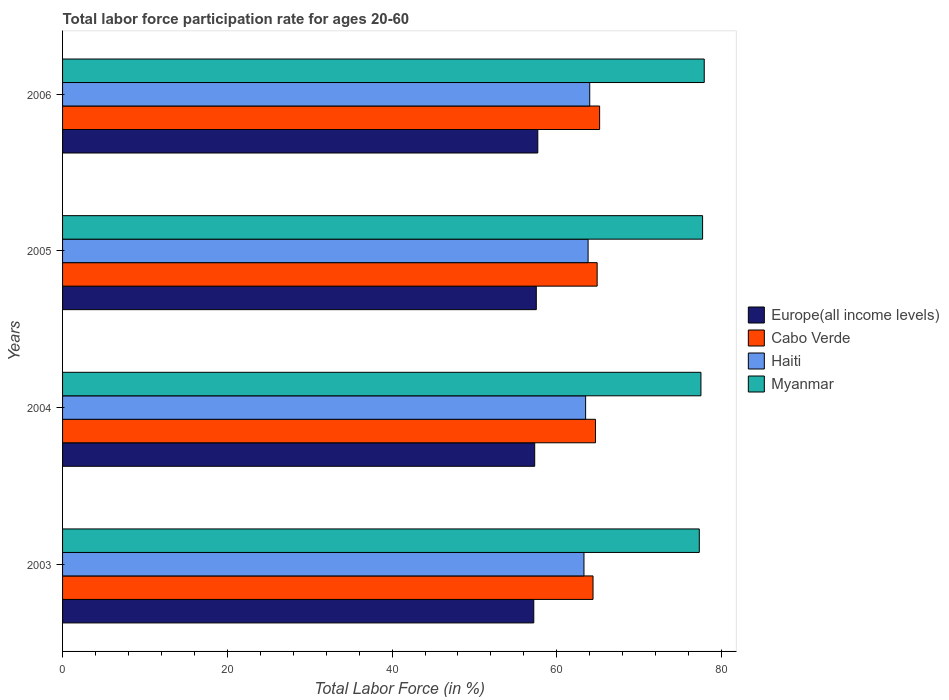How many bars are there on the 2nd tick from the bottom?
Your answer should be very brief. 4. What is the label of the 1st group of bars from the top?
Give a very brief answer. 2006. What is the labor force participation rate in Myanmar in 2006?
Ensure brevity in your answer.  77.9. Across all years, what is the maximum labor force participation rate in Haiti?
Provide a succinct answer. 64. Across all years, what is the minimum labor force participation rate in Europe(all income levels)?
Offer a terse response. 57.21. In which year was the labor force participation rate in Haiti maximum?
Offer a terse response. 2006. In which year was the labor force participation rate in Haiti minimum?
Give a very brief answer. 2003. What is the total labor force participation rate in Europe(all income levels) in the graph?
Provide a succinct answer. 229.73. What is the difference between the labor force participation rate in Europe(all income levels) in 2003 and that in 2004?
Provide a succinct answer. -0.11. What is the difference between the labor force participation rate in Cabo Verde in 2004 and the labor force participation rate in Myanmar in 2003?
Offer a terse response. -12.6. What is the average labor force participation rate in Cabo Verde per year?
Offer a terse response. 64.8. In the year 2005, what is the difference between the labor force participation rate in Europe(all income levels) and labor force participation rate in Haiti?
Keep it short and to the point. -6.29. What is the ratio of the labor force participation rate in Haiti in 2004 to that in 2006?
Keep it short and to the point. 0.99. What is the difference between the highest and the second highest labor force participation rate in Myanmar?
Ensure brevity in your answer.  0.2. What is the difference between the highest and the lowest labor force participation rate in Cabo Verde?
Your response must be concise. 0.8. Is it the case that in every year, the sum of the labor force participation rate in Europe(all income levels) and labor force participation rate in Haiti is greater than the sum of labor force participation rate in Myanmar and labor force participation rate in Cabo Verde?
Offer a very short reply. No. What does the 4th bar from the top in 2003 represents?
Offer a terse response. Europe(all income levels). What does the 3rd bar from the bottom in 2003 represents?
Provide a succinct answer. Haiti. How many bars are there?
Give a very brief answer. 16. How many years are there in the graph?
Make the answer very short. 4. Are the values on the major ticks of X-axis written in scientific E-notation?
Your answer should be very brief. No. Does the graph contain any zero values?
Your answer should be very brief. No. Does the graph contain grids?
Your response must be concise. No. Where does the legend appear in the graph?
Keep it short and to the point. Center right. What is the title of the graph?
Provide a short and direct response. Total labor force participation rate for ages 20-60. Does "New Caledonia" appear as one of the legend labels in the graph?
Offer a very short reply. No. What is the Total Labor Force (in %) in Europe(all income levels) in 2003?
Your response must be concise. 57.21. What is the Total Labor Force (in %) in Cabo Verde in 2003?
Ensure brevity in your answer.  64.4. What is the Total Labor Force (in %) in Haiti in 2003?
Ensure brevity in your answer.  63.3. What is the Total Labor Force (in %) of Myanmar in 2003?
Keep it short and to the point. 77.3. What is the Total Labor Force (in %) in Europe(all income levels) in 2004?
Offer a terse response. 57.32. What is the Total Labor Force (in %) in Cabo Verde in 2004?
Your answer should be compact. 64.7. What is the Total Labor Force (in %) of Haiti in 2004?
Provide a succinct answer. 63.5. What is the Total Labor Force (in %) of Myanmar in 2004?
Your response must be concise. 77.5. What is the Total Labor Force (in %) of Europe(all income levels) in 2005?
Offer a very short reply. 57.51. What is the Total Labor Force (in %) in Cabo Verde in 2005?
Provide a short and direct response. 64.9. What is the Total Labor Force (in %) of Haiti in 2005?
Offer a very short reply. 63.8. What is the Total Labor Force (in %) in Myanmar in 2005?
Keep it short and to the point. 77.7. What is the Total Labor Force (in %) in Europe(all income levels) in 2006?
Offer a very short reply. 57.69. What is the Total Labor Force (in %) of Cabo Verde in 2006?
Your response must be concise. 65.2. What is the Total Labor Force (in %) in Myanmar in 2006?
Ensure brevity in your answer.  77.9. Across all years, what is the maximum Total Labor Force (in %) of Europe(all income levels)?
Give a very brief answer. 57.69. Across all years, what is the maximum Total Labor Force (in %) of Cabo Verde?
Offer a very short reply. 65.2. Across all years, what is the maximum Total Labor Force (in %) in Haiti?
Offer a very short reply. 64. Across all years, what is the maximum Total Labor Force (in %) in Myanmar?
Provide a succinct answer. 77.9. Across all years, what is the minimum Total Labor Force (in %) of Europe(all income levels)?
Keep it short and to the point. 57.21. Across all years, what is the minimum Total Labor Force (in %) in Cabo Verde?
Give a very brief answer. 64.4. Across all years, what is the minimum Total Labor Force (in %) in Haiti?
Provide a short and direct response. 63.3. Across all years, what is the minimum Total Labor Force (in %) in Myanmar?
Offer a terse response. 77.3. What is the total Total Labor Force (in %) in Europe(all income levels) in the graph?
Offer a terse response. 229.73. What is the total Total Labor Force (in %) of Cabo Verde in the graph?
Keep it short and to the point. 259.2. What is the total Total Labor Force (in %) in Haiti in the graph?
Provide a short and direct response. 254.6. What is the total Total Labor Force (in %) of Myanmar in the graph?
Offer a very short reply. 310.4. What is the difference between the Total Labor Force (in %) in Europe(all income levels) in 2003 and that in 2004?
Keep it short and to the point. -0.11. What is the difference between the Total Labor Force (in %) in Cabo Verde in 2003 and that in 2004?
Keep it short and to the point. -0.3. What is the difference between the Total Labor Force (in %) of Haiti in 2003 and that in 2004?
Make the answer very short. -0.2. What is the difference between the Total Labor Force (in %) of Europe(all income levels) in 2003 and that in 2005?
Your response must be concise. -0.3. What is the difference between the Total Labor Force (in %) of Cabo Verde in 2003 and that in 2005?
Your response must be concise. -0.5. What is the difference between the Total Labor Force (in %) of Myanmar in 2003 and that in 2005?
Offer a very short reply. -0.4. What is the difference between the Total Labor Force (in %) of Europe(all income levels) in 2003 and that in 2006?
Your answer should be very brief. -0.49. What is the difference between the Total Labor Force (in %) in Cabo Verde in 2003 and that in 2006?
Provide a succinct answer. -0.8. What is the difference between the Total Labor Force (in %) of Myanmar in 2003 and that in 2006?
Keep it short and to the point. -0.6. What is the difference between the Total Labor Force (in %) in Europe(all income levels) in 2004 and that in 2005?
Keep it short and to the point. -0.19. What is the difference between the Total Labor Force (in %) in Cabo Verde in 2004 and that in 2005?
Offer a terse response. -0.2. What is the difference between the Total Labor Force (in %) in Haiti in 2004 and that in 2005?
Offer a terse response. -0.3. What is the difference between the Total Labor Force (in %) of Myanmar in 2004 and that in 2005?
Offer a very short reply. -0.2. What is the difference between the Total Labor Force (in %) of Europe(all income levels) in 2004 and that in 2006?
Give a very brief answer. -0.37. What is the difference between the Total Labor Force (in %) of Cabo Verde in 2004 and that in 2006?
Provide a short and direct response. -0.5. What is the difference between the Total Labor Force (in %) in Europe(all income levels) in 2005 and that in 2006?
Offer a terse response. -0.18. What is the difference between the Total Labor Force (in %) of Cabo Verde in 2005 and that in 2006?
Make the answer very short. -0.3. What is the difference between the Total Labor Force (in %) of Europe(all income levels) in 2003 and the Total Labor Force (in %) of Cabo Verde in 2004?
Make the answer very short. -7.49. What is the difference between the Total Labor Force (in %) of Europe(all income levels) in 2003 and the Total Labor Force (in %) of Haiti in 2004?
Make the answer very short. -6.29. What is the difference between the Total Labor Force (in %) in Europe(all income levels) in 2003 and the Total Labor Force (in %) in Myanmar in 2004?
Give a very brief answer. -20.29. What is the difference between the Total Labor Force (in %) in Cabo Verde in 2003 and the Total Labor Force (in %) in Haiti in 2004?
Your answer should be very brief. 0.9. What is the difference between the Total Labor Force (in %) of Haiti in 2003 and the Total Labor Force (in %) of Myanmar in 2004?
Your answer should be very brief. -14.2. What is the difference between the Total Labor Force (in %) in Europe(all income levels) in 2003 and the Total Labor Force (in %) in Cabo Verde in 2005?
Offer a terse response. -7.69. What is the difference between the Total Labor Force (in %) in Europe(all income levels) in 2003 and the Total Labor Force (in %) in Haiti in 2005?
Make the answer very short. -6.59. What is the difference between the Total Labor Force (in %) in Europe(all income levels) in 2003 and the Total Labor Force (in %) in Myanmar in 2005?
Provide a short and direct response. -20.49. What is the difference between the Total Labor Force (in %) of Cabo Verde in 2003 and the Total Labor Force (in %) of Haiti in 2005?
Give a very brief answer. 0.6. What is the difference between the Total Labor Force (in %) in Haiti in 2003 and the Total Labor Force (in %) in Myanmar in 2005?
Offer a terse response. -14.4. What is the difference between the Total Labor Force (in %) in Europe(all income levels) in 2003 and the Total Labor Force (in %) in Cabo Verde in 2006?
Make the answer very short. -7.99. What is the difference between the Total Labor Force (in %) in Europe(all income levels) in 2003 and the Total Labor Force (in %) in Haiti in 2006?
Offer a terse response. -6.79. What is the difference between the Total Labor Force (in %) in Europe(all income levels) in 2003 and the Total Labor Force (in %) in Myanmar in 2006?
Ensure brevity in your answer.  -20.69. What is the difference between the Total Labor Force (in %) in Haiti in 2003 and the Total Labor Force (in %) in Myanmar in 2006?
Offer a very short reply. -14.6. What is the difference between the Total Labor Force (in %) in Europe(all income levels) in 2004 and the Total Labor Force (in %) in Cabo Verde in 2005?
Your response must be concise. -7.58. What is the difference between the Total Labor Force (in %) in Europe(all income levels) in 2004 and the Total Labor Force (in %) in Haiti in 2005?
Give a very brief answer. -6.48. What is the difference between the Total Labor Force (in %) in Europe(all income levels) in 2004 and the Total Labor Force (in %) in Myanmar in 2005?
Keep it short and to the point. -20.38. What is the difference between the Total Labor Force (in %) in Cabo Verde in 2004 and the Total Labor Force (in %) in Myanmar in 2005?
Give a very brief answer. -13. What is the difference between the Total Labor Force (in %) of Europe(all income levels) in 2004 and the Total Labor Force (in %) of Cabo Verde in 2006?
Provide a short and direct response. -7.88. What is the difference between the Total Labor Force (in %) in Europe(all income levels) in 2004 and the Total Labor Force (in %) in Haiti in 2006?
Ensure brevity in your answer.  -6.68. What is the difference between the Total Labor Force (in %) of Europe(all income levels) in 2004 and the Total Labor Force (in %) of Myanmar in 2006?
Make the answer very short. -20.58. What is the difference between the Total Labor Force (in %) in Cabo Verde in 2004 and the Total Labor Force (in %) in Myanmar in 2006?
Your answer should be compact. -13.2. What is the difference between the Total Labor Force (in %) in Haiti in 2004 and the Total Labor Force (in %) in Myanmar in 2006?
Offer a very short reply. -14.4. What is the difference between the Total Labor Force (in %) of Europe(all income levels) in 2005 and the Total Labor Force (in %) of Cabo Verde in 2006?
Provide a succinct answer. -7.69. What is the difference between the Total Labor Force (in %) in Europe(all income levels) in 2005 and the Total Labor Force (in %) in Haiti in 2006?
Your answer should be very brief. -6.49. What is the difference between the Total Labor Force (in %) in Europe(all income levels) in 2005 and the Total Labor Force (in %) in Myanmar in 2006?
Make the answer very short. -20.39. What is the difference between the Total Labor Force (in %) in Cabo Verde in 2005 and the Total Labor Force (in %) in Haiti in 2006?
Offer a very short reply. 0.9. What is the difference between the Total Labor Force (in %) of Cabo Verde in 2005 and the Total Labor Force (in %) of Myanmar in 2006?
Provide a short and direct response. -13. What is the difference between the Total Labor Force (in %) of Haiti in 2005 and the Total Labor Force (in %) of Myanmar in 2006?
Keep it short and to the point. -14.1. What is the average Total Labor Force (in %) in Europe(all income levels) per year?
Your response must be concise. 57.43. What is the average Total Labor Force (in %) of Cabo Verde per year?
Provide a succinct answer. 64.8. What is the average Total Labor Force (in %) in Haiti per year?
Your answer should be compact. 63.65. What is the average Total Labor Force (in %) in Myanmar per year?
Offer a terse response. 77.6. In the year 2003, what is the difference between the Total Labor Force (in %) of Europe(all income levels) and Total Labor Force (in %) of Cabo Verde?
Provide a short and direct response. -7.19. In the year 2003, what is the difference between the Total Labor Force (in %) of Europe(all income levels) and Total Labor Force (in %) of Haiti?
Give a very brief answer. -6.09. In the year 2003, what is the difference between the Total Labor Force (in %) in Europe(all income levels) and Total Labor Force (in %) in Myanmar?
Your answer should be very brief. -20.09. In the year 2003, what is the difference between the Total Labor Force (in %) of Cabo Verde and Total Labor Force (in %) of Myanmar?
Your response must be concise. -12.9. In the year 2004, what is the difference between the Total Labor Force (in %) of Europe(all income levels) and Total Labor Force (in %) of Cabo Verde?
Give a very brief answer. -7.38. In the year 2004, what is the difference between the Total Labor Force (in %) in Europe(all income levels) and Total Labor Force (in %) in Haiti?
Keep it short and to the point. -6.18. In the year 2004, what is the difference between the Total Labor Force (in %) of Europe(all income levels) and Total Labor Force (in %) of Myanmar?
Make the answer very short. -20.18. In the year 2004, what is the difference between the Total Labor Force (in %) of Cabo Verde and Total Labor Force (in %) of Haiti?
Provide a short and direct response. 1.2. In the year 2004, what is the difference between the Total Labor Force (in %) in Haiti and Total Labor Force (in %) in Myanmar?
Give a very brief answer. -14. In the year 2005, what is the difference between the Total Labor Force (in %) of Europe(all income levels) and Total Labor Force (in %) of Cabo Verde?
Your answer should be compact. -7.39. In the year 2005, what is the difference between the Total Labor Force (in %) of Europe(all income levels) and Total Labor Force (in %) of Haiti?
Your answer should be compact. -6.29. In the year 2005, what is the difference between the Total Labor Force (in %) of Europe(all income levels) and Total Labor Force (in %) of Myanmar?
Your response must be concise. -20.19. In the year 2005, what is the difference between the Total Labor Force (in %) of Haiti and Total Labor Force (in %) of Myanmar?
Ensure brevity in your answer.  -13.9. In the year 2006, what is the difference between the Total Labor Force (in %) of Europe(all income levels) and Total Labor Force (in %) of Cabo Verde?
Ensure brevity in your answer.  -7.51. In the year 2006, what is the difference between the Total Labor Force (in %) of Europe(all income levels) and Total Labor Force (in %) of Haiti?
Give a very brief answer. -6.31. In the year 2006, what is the difference between the Total Labor Force (in %) in Europe(all income levels) and Total Labor Force (in %) in Myanmar?
Offer a terse response. -20.21. In the year 2006, what is the difference between the Total Labor Force (in %) in Cabo Verde and Total Labor Force (in %) in Myanmar?
Give a very brief answer. -12.7. What is the ratio of the Total Labor Force (in %) of Cabo Verde in 2003 to that in 2004?
Your answer should be very brief. 1. What is the ratio of the Total Labor Force (in %) in Haiti in 2003 to that in 2004?
Provide a succinct answer. 1. What is the ratio of the Total Labor Force (in %) in Myanmar in 2003 to that in 2004?
Provide a short and direct response. 1. What is the ratio of the Total Labor Force (in %) of Europe(all income levels) in 2003 to that in 2005?
Give a very brief answer. 0.99. What is the ratio of the Total Labor Force (in %) in Europe(all income levels) in 2003 to that in 2006?
Provide a short and direct response. 0.99. What is the ratio of the Total Labor Force (in %) in Myanmar in 2003 to that in 2006?
Your response must be concise. 0.99. What is the ratio of the Total Labor Force (in %) in Cabo Verde in 2004 to that in 2005?
Give a very brief answer. 1. What is the ratio of the Total Labor Force (in %) in Myanmar in 2004 to that in 2005?
Ensure brevity in your answer.  1. What is the ratio of the Total Labor Force (in %) in Europe(all income levels) in 2004 to that in 2006?
Provide a succinct answer. 0.99. What is the ratio of the Total Labor Force (in %) of Haiti in 2004 to that in 2006?
Your response must be concise. 0.99. What is the ratio of the Total Labor Force (in %) in Myanmar in 2004 to that in 2006?
Offer a very short reply. 0.99. What is the ratio of the Total Labor Force (in %) in Cabo Verde in 2005 to that in 2006?
Give a very brief answer. 1. What is the difference between the highest and the second highest Total Labor Force (in %) in Europe(all income levels)?
Ensure brevity in your answer.  0.18. What is the difference between the highest and the second highest Total Labor Force (in %) in Cabo Verde?
Your answer should be very brief. 0.3. What is the difference between the highest and the lowest Total Labor Force (in %) of Europe(all income levels)?
Provide a succinct answer. 0.49. What is the difference between the highest and the lowest Total Labor Force (in %) in Haiti?
Provide a short and direct response. 0.7. What is the difference between the highest and the lowest Total Labor Force (in %) in Myanmar?
Provide a succinct answer. 0.6. 